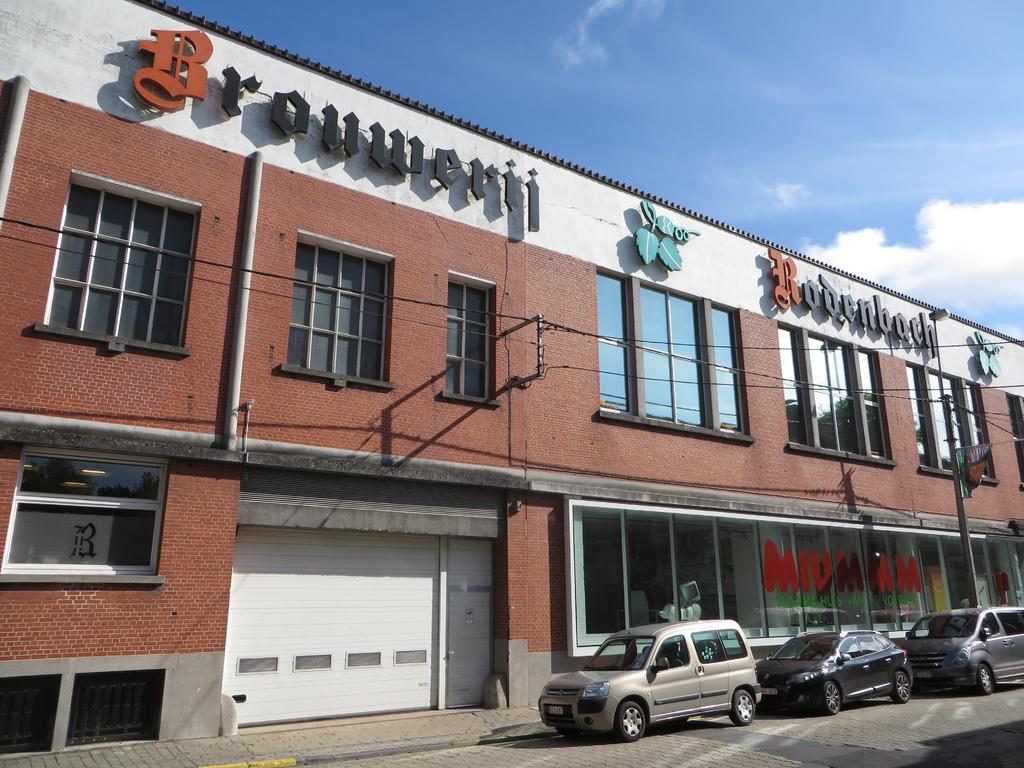What vehicles are located on the right side of the image? There are three cars on the right side of the image. What type of structure can be seen in the image? There is a building in the image. What color is the shutter in the image? The shutter is white in color. What is written at the top of the image? There is text written at the top of the image. How many birds are sitting on the roof of the building in the image? There are no birds visible in the image; it only shows three cars, a building, a white shutter, and text at the top. What type of roll is being used to hold the text at the top of the image? There is no roll present in the image; the text is simply written at the top. 